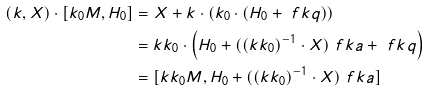Convert formula to latex. <formula><loc_0><loc_0><loc_500><loc_500>( k , X ) \cdot [ k _ { 0 } M , H _ { 0 } ] & = X + k \cdot \left ( k _ { 0 } \cdot ( H _ { 0 } + \ f k q ) \right ) \\ & = k k _ { 0 } \cdot \left ( H _ { 0 } + ( ( k k _ { 0 } ) ^ { - 1 } \cdot X ) _ { \ } f k a + \ f k q \right ) \\ & = [ k k _ { 0 } M , H _ { 0 } + ( ( k k _ { 0 } ) ^ { - 1 } \cdot X ) _ { \ } f k a ]</formula> 